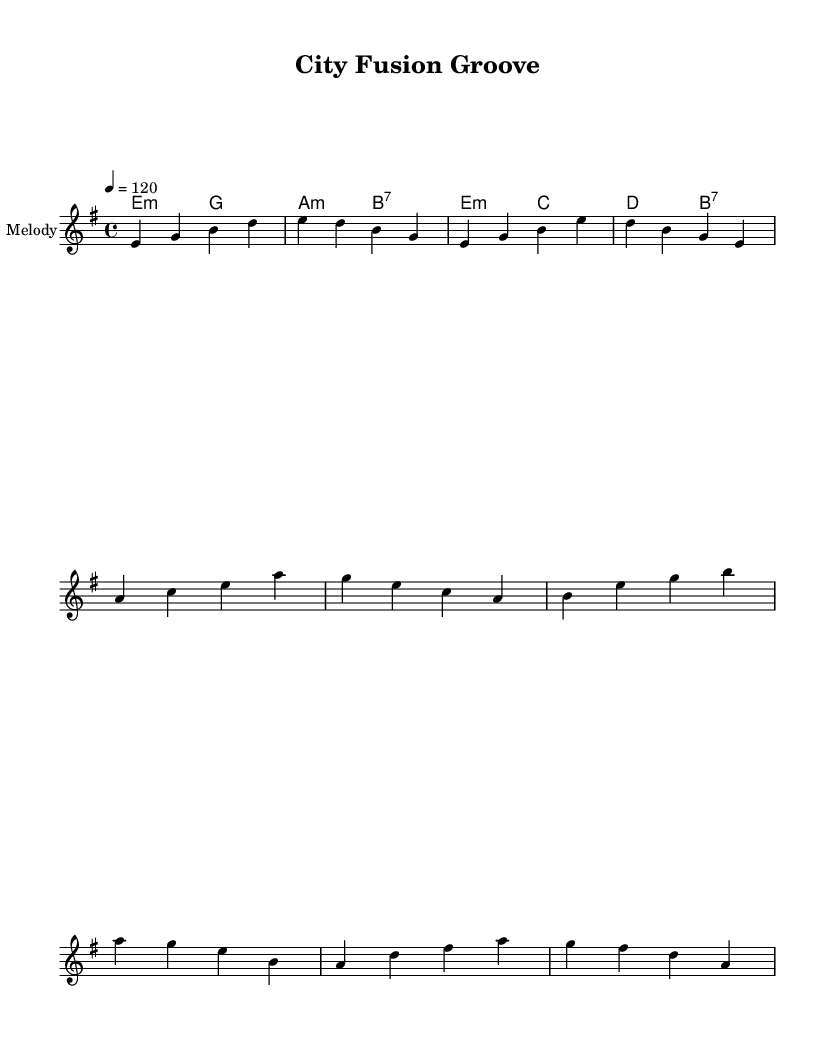What is the key signature of this music? The key signature shown in the music indicates E minor, as it includes one sharp (F#) which corresponds to the key of E minor.
Answer: E minor What is the time signature of this music? The time signature displayed in the music is 4/4, meaning there are four beats in each measure, and the quarter note gets one beat.
Answer: 4/4 What is the tempo marking of this music? The tempo marking indicated is 120 beats per minute, which suggests a moderately fast pace.
Answer: 120 How many measures are in the verse section? By analyzing the melody, we see that the verse consists of four measures before moving to the chorus.
Answer: 4 What type of chords are used in the harmony section? The harmony consists of minor and seventh chords, reflecting the funk-infused disco style commonly found in this genre.
Answer: minor and seventh What is the overall structure of the piece? The music follows a structure of Intro, Verse, and Chorus, a common arrangement in disco tracks often associated with danceable rhythms.
Answer: Intro, Verse, Chorus Which instrument is specified for the melody? The notation indicates that the melody is intended for a single staff, as shown by the instrument name "Melody" in the score.
Answer: Melody 